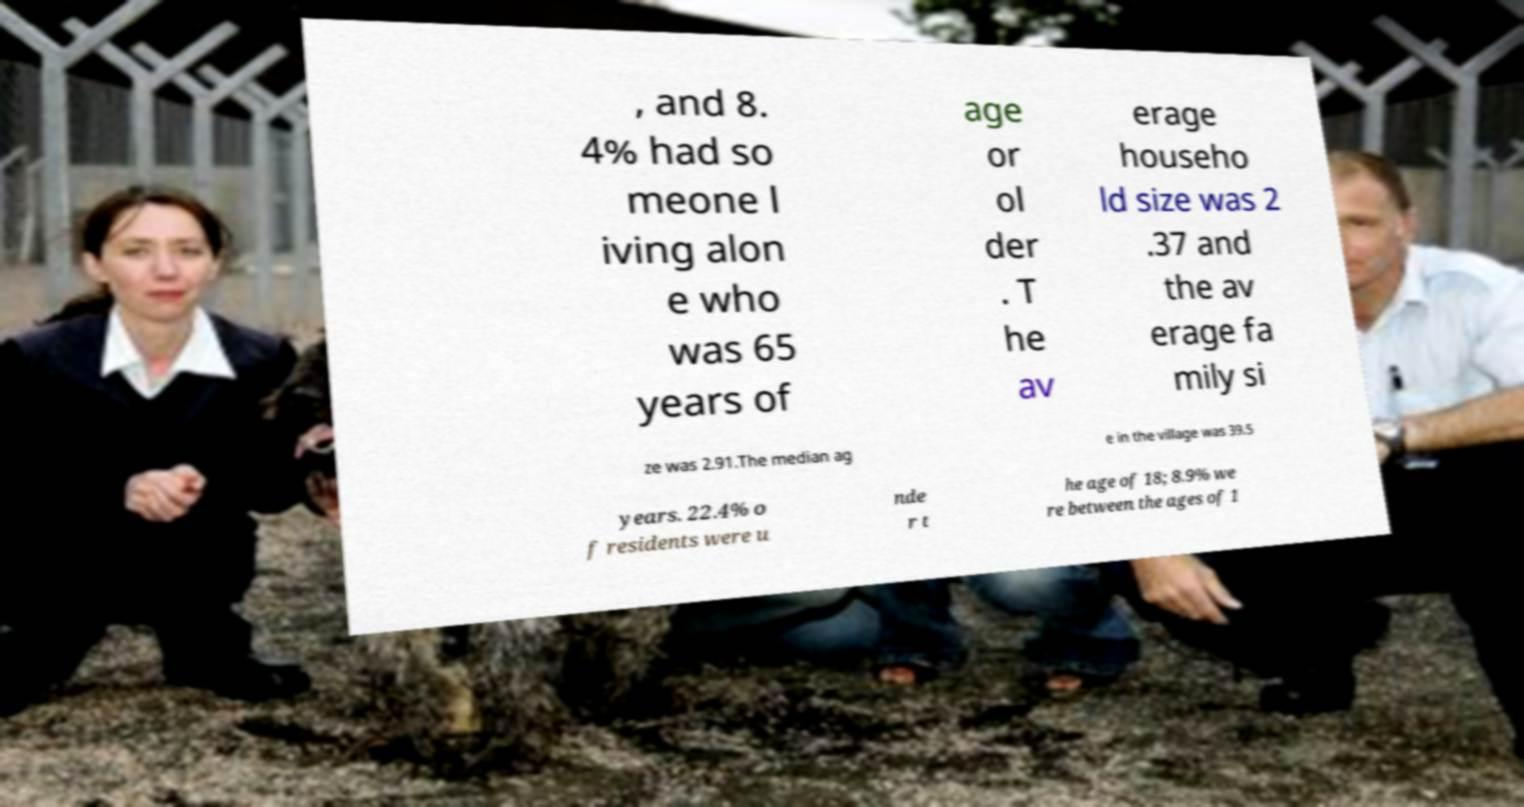Please identify and transcribe the text found in this image. , and 8. 4% had so meone l iving alon e who was 65 years of age or ol der . T he av erage househo ld size was 2 .37 and the av erage fa mily si ze was 2.91.The median ag e in the village was 39.5 years. 22.4% o f residents were u nde r t he age of 18; 8.9% we re between the ages of 1 